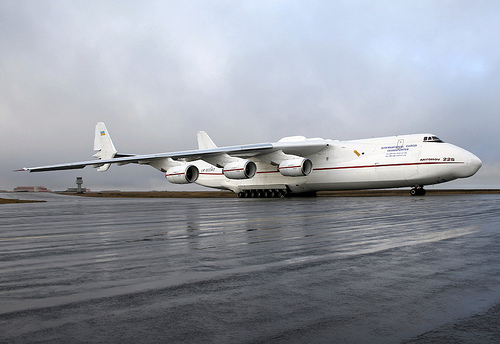<image>
Is there a plane above the water? Yes. The plane is positioned above the water in the vertical space, higher up in the scene. 